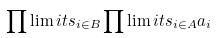<formula> <loc_0><loc_0><loc_500><loc_500>\prod \lim i t s _ { i \in B } \prod \lim i t s _ { i \in A } a _ { i }</formula> 